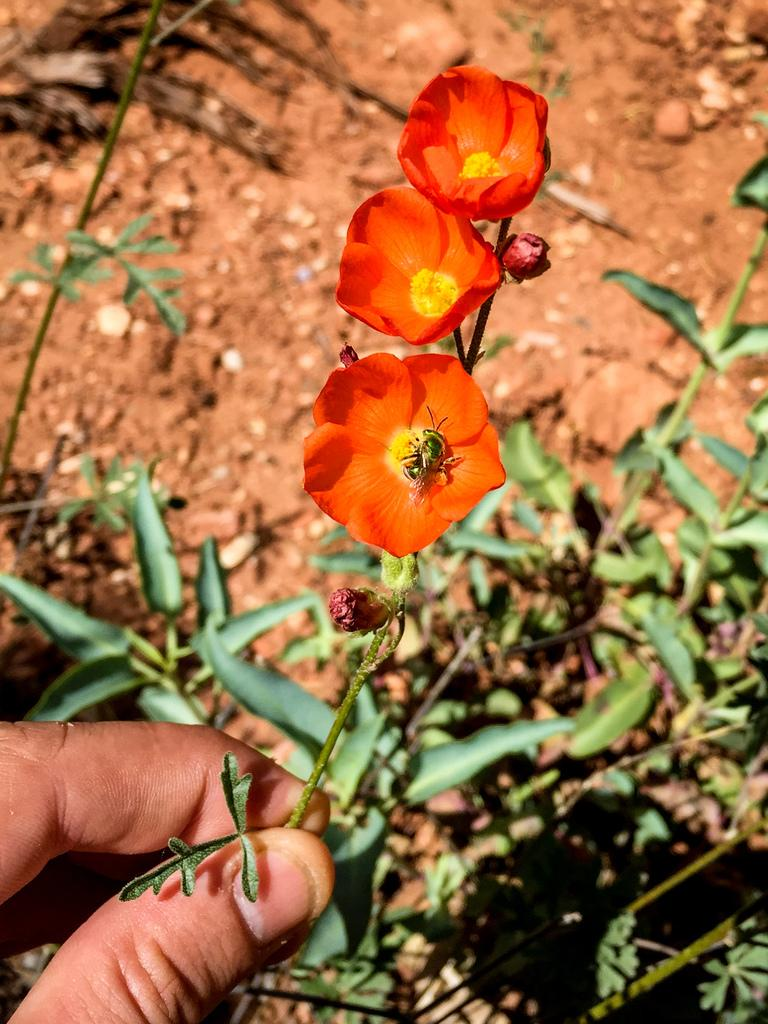What is being held by the human hand in the image? There is a human hand holding flowers in the image. What is the color of the flowers being held? The flowers are orange in color. What can be seen in the background of the image? Leaves and stems are present in the background of the image. What type of terrain is visible in the image? There is sandy land visible in the image. What type of peace symbol can be seen on the plate in the image? There is no plate or peace symbol present in the image. How many stockings are hanging on the wall in the image? There is no wall or stockings present in the image. 